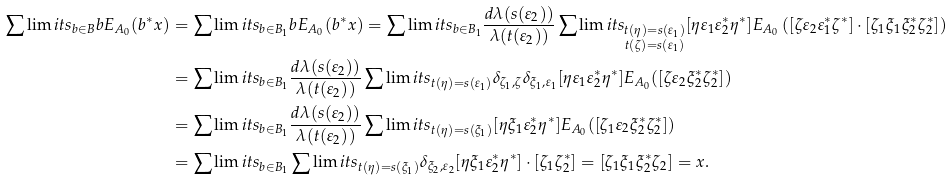Convert formula to latex. <formula><loc_0><loc_0><loc_500><loc_500>\sum \lim i t s _ { b \in B } b E _ { A _ { 0 } } ( b ^ { * } x ) & = \sum \lim i t s _ { b \in B _ { 1 } } b E _ { A _ { 0 } } ( b ^ { * } x ) = \sum \lim i t s _ { b \in B _ { 1 } } \frac { d \lambda ( s ( \varepsilon _ { 2 } ) ) } { \lambda ( t ( \varepsilon _ { 2 } ) ) } \sum \lim i t s _ { \substack { t ( \eta ) = s ( \varepsilon _ { 1 } ) \\ t ( \zeta ) = s ( \varepsilon _ { 1 } ) } } [ \eta \varepsilon _ { 1 } \varepsilon _ { 2 } ^ { * } \eta ^ { * } ] E _ { A _ { 0 } } \left ( [ \zeta \varepsilon _ { 2 } \varepsilon _ { 1 } ^ { * } \zeta ^ { * } ] \cdot [ \zeta _ { 1 } \xi _ { 1 } \xi _ { 2 } ^ { * } \zeta _ { 2 } ^ { * } ] \right ) \\ & = \sum \lim i t s _ { b \in B _ { 1 } } \frac { d \lambda ( s ( \varepsilon _ { 2 } ) ) } { \lambda ( t ( \varepsilon _ { 2 } ) ) } \sum \lim i t s _ { t ( \eta ) = s ( \varepsilon _ { 1 } ) } \delta _ { \zeta _ { 1 } , \zeta } \delta _ { \xi _ { 1 } , \varepsilon _ { 1 } } [ \eta \varepsilon _ { 1 } \varepsilon _ { 2 } ^ { * } \eta ^ { * } ] E _ { A _ { 0 } } ( [ \zeta \varepsilon _ { 2 } \xi _ { 2 } ^ { * } \zeta ^ { * } _ { 2 } ] ) \\ & = \sum \lim i t s _ { b \in B _ { 1 } } \frac { d \lambda ( s ( \varepsilon _ { 2 } ) ) } { \lambda ( t ( \varepsilon _ { 2 } ) ) } \sum \lim i t s _ { t ( \eta ) = s ( \xi _ { 1 } ) } [ \eta \xi _ { 1 } \varepsilon _ { 2 } ^ { * } \eta ^ { * } ] E _ { A _ { 0 } } ( [ \zeta _ { 1 } \varepsilon _ { 2 } \xi _ { 2 } ^ { * } \zeta ^ { * } _ { 2 } ] ) \\ & = \sum \lim i t s _ { b \in B _ { 1 } } \sum \lim i t s _ { t ( \eta ) = s ( \xi _ { 1 } ) } \delta _ { \xi _ { 2 } , \varepsilon _ { 2 } } [ \eta \xi _ { 1 } \varepsilon _ { 2 } ^ { * } \eta ^ { * } ] \cdot [ \zeta _ { 1 } \zeta ^ { * } _ { 2 } ] = [ \zeta _ { 1 } \xi _ { 1 } \xi _ { 2 } ^ { * } \zeta _ { 2 } ] = x .</formula> 